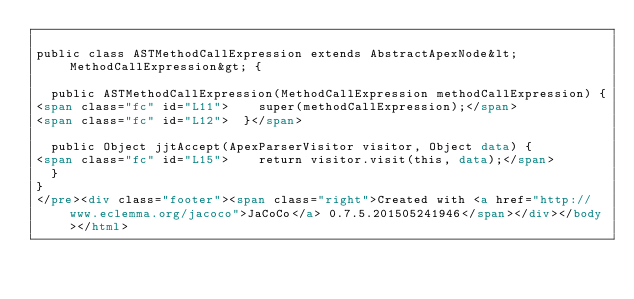<code> <loc_0><loc_0><loc_500><loc_500><_HTML_>
public class ASTMethodCallExpression extends AbstractApexNode&lt;MethodCallExpression&gt; {

	public ASTMethodCallExpression(MethodCallExpression methodCallExpression) {
<span class="fc" id="L11">		super(methodCallExpression);</span>
<span class="fc" id="L12">	}</span>

	public Object jjtAccept(ApexParserVisitor visitor, Object data) {
<span class="fc" id="L15">		return visitor.visit(this, data);</span>
	}
}
</pre><div class="footer"><span class="right">Created with <a href="http://www.eclemma.org/jacoco">JaCoCo</a> 0.7.5.201505241946</span></div></body></html></code> 